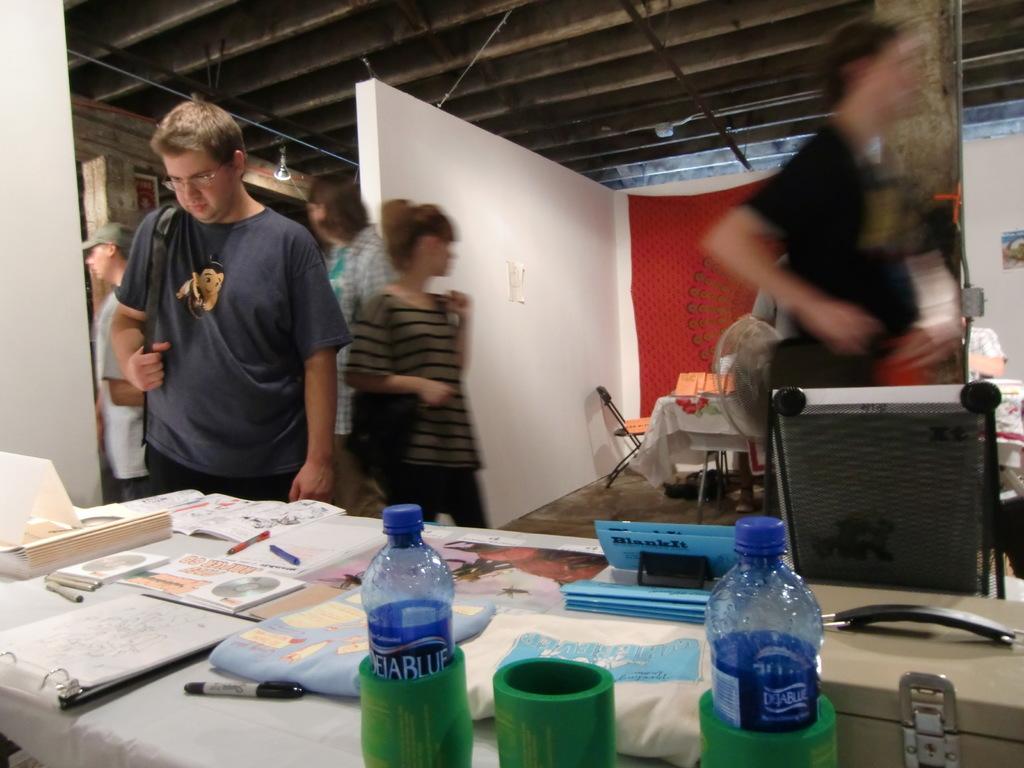What is the drink?
Provide a succinct answer. Dejablue. What is the drink name?
Provide a short and direct response. Dejablue. 